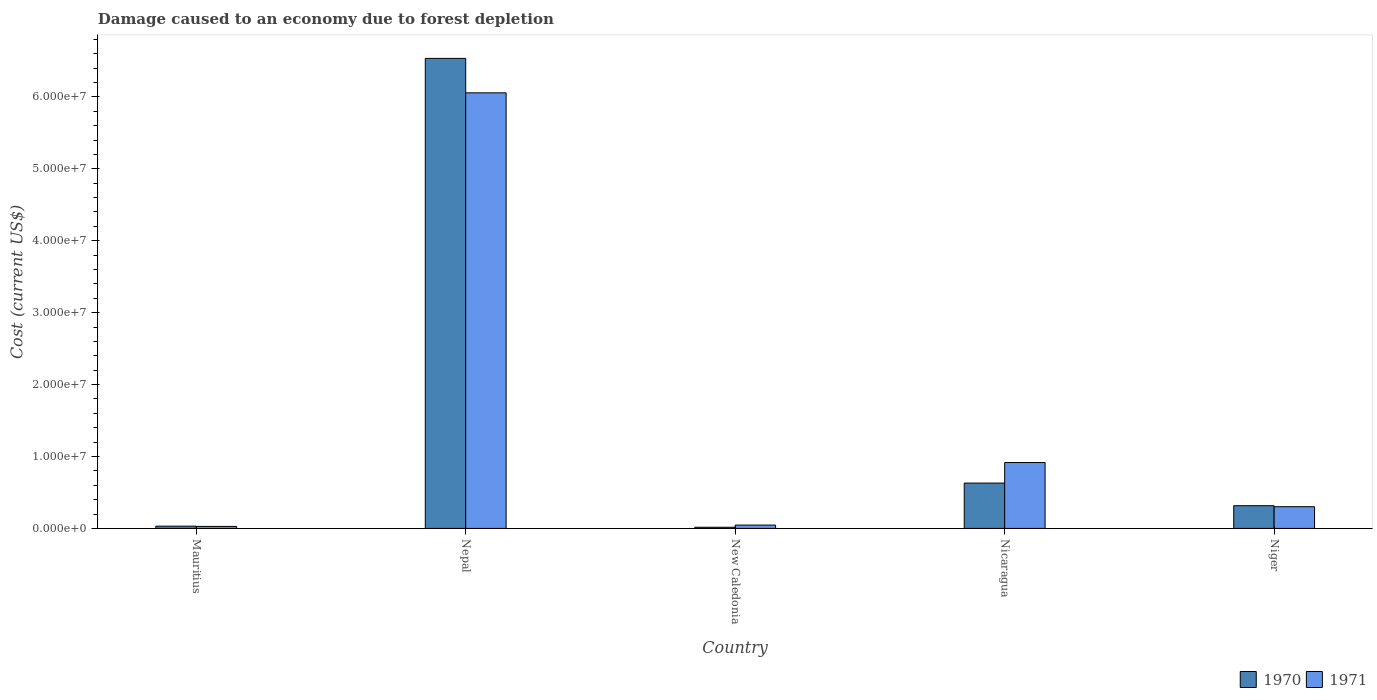How many groups of bars are there?
Ensure brevity in your answer.  5. Are the number of bars per tick equal to the number of legend labels?
Offer a terse response. Yes. How many bars are there on the 3rd tick from the left?
Keep it short and to the point. 2. What is the label of the 1st group of bars from the left?
Make the answer very short. Mauritius. In how many cases, is the number of bars for a given country not equal to the number of legend labels?
Provide a succinct answer. 0. What is the cost of damage caused due to forest depletion in 1971 in Nicaragua?
Ensure brevity in your answer.  9.16e+06. Across all countries, what is the maximum cost of damage caused due to forest depletion in 1971?
Provide a short and direct response. 6.06e+07. Across all countries, what is the minimum cost of damage caused due to forest depletion in 1971?
Your response must be concise. 2.78e+05. In which country was the cost of damage caused due to forest depletion in 1970 maximum?
Keep it short and to the point. Nepal. In which country was the cost of damage caused due to forest depletion in 1970 minimum?
Keep it short and to the point. New Caledonia. What is the total cost of damage caused due to forest depletion in 1971 in the graph?
Provide a succinct answer. 7.35e+07. What is the difference between the cost of damage caused due to forest depletion in 1971 in Mauritius and that in New Caledonia?
Make the answer very short. -1.87e+05. What is the difference between the cost of damage caused due to forest depletion in 1971 in Mauritius and the cost of damage caused due to forest depletion in 1970 in Niger?
Keep it short and to the point. -2.88e+06. What is the average cost of damage caused due to forest depletion in 1970 per country?
Ensure brevity in your answer.  1.51e+07. What is the difference between the cost of damage caused due to forest depletion of/in 1970 and cost of damage caused due to forest depletion of/in 1971 in Nepal?
Your answer should be compact. 4.79e+06. In how many countries, is the cost of damage caused due to forest depletion in 1971 greater than 34000000 US$?
Your answer should be very brief. 1. What is the ratio of the cost of damage caused due to forest depletion in 1970 in Mauritius to that in Nicaragua?
Keep it short and to the point. 0.05. Is the cost of damage caused due to forest depletion in 1970 in Mauritius less than that in Nepal?
Provide a short and direct response. Yes. What is the difference between the highest and the second highest cost of damage caused due to forest depletion in 1970?
Your answer should be compact. 6.22e+07. What is the difference between the highest and the lowest cost of damage caused due to forest depletion in 1970?
Give a very brief answer. 6.52e+07. Are all the bars in the graph horizontal?
Provide a succinct answer. No. How many countries are there in the graph?
Your response must be concise. 5. What is the difference between two consecutive major ticks on the Y-axis?
Keep it short and to the point. 1.00e+07. Are the values on the major ticks of Y-axis written in scientific E-notation?
Offer a terse response. Yes. Does the graph contain any zero values?
Ensure brevity in your answer.  No. Where does the legend appear in the graph?
Offer a very short reply. Bottom right. How many legend labels are there?
Your response must be concise. 2. How are the legend labels stacked?
Your answer should be compact. Horizontal. What is the title of the graph?
Offer a very short reply. Damage caused to an economy due to forest depletion. Does "2009" appear as one of the legend labels in the graph?
Your answer should be very brief. No. What is the label or title of the X-axis?
Offer a very short reply. Country. What is the label or title of the Y-axis?
Provide a succinct answer. Cost (current US$). What is the Cost (current US$) of 1970 in Mauritius?
Your response must be concise. 3.14e+05. What is the Cost (current US$) in 1971 in Mauritius?
Ensure brevity in your answer.  2.78e+05. What is the Cost (current US$) in 1970 in Nepal?
Your answer should be compact. 6.54e+07. What is the Cost (current US$) in 1971 in Nepal?
Your response must be concise. 6.06e+07. What is the Cost (current US$) of 1970 in New Caledonia?
Your answer should be compact. 1.60e+05. What is the Cost (current US$) of 1971 in New Caledonia?
Offer a very short reply. 4.65e+05. What is the Cost (current US$) of 1970 in Nicaragua?
Keep it short and to the point. 6.30e+06. What is the Cost (current US$) of 1971 in Nicaragua?
Make the answer very short. 9.16e+06. What is the Cost (current US$) of 1970 in Niger?
Your response must be concise. 3.16e+06. What is the Cost (current US$) in 1971 in Niger?
Ensure brevity in your answer.  3.02e+06. Across all countries, what is the maximum Cost (current US$) in 1970?
Your answer should be very brief. 6.54e+07. Across all countries, what is the maximum Cost (current US$) of 1971?
Your response must be concise. 6.06e+07. Across all countries, what is the minimum Cost (current US$) in 1970?
Your answer should be compact. 1.60e+05. Across all countries, what is the minimum Cost (current US$) of 1971?
Ensure brevity in your answer.  2.78e+05. What is the total Cost (current US$) in 1970 in the graph?
Make the answer very short. 7.53e+07. What is the total Cost (current US$) in 1971 in the graph?
Make the answer very short. 7.35e+07. What is the difference between the Cost (current US$) in 1970 in Mauritius and that in Nepal?
Keep it short and to the point. -6.50e+07. What is the difference between the Cost (current US$) of 1971 in Mauritius and that in Nepal?
Make the answer very short. -6.03e+07. What is the difference between the Cost (current US$) of 1970 in Mauritius and that in New Caledonia?
Make the answer very short. 1.54e+05. What is the difference between the Cost (current US$) in 1971 in Mauritius and that in New Caledonia?
Provide a short and direct response. -1.87e+05. What is the difference between the Cost (current US$) of 1970 in Mauritius and that in Nicaragua?
Provide a succinct answer. -5.99e+06. What is the difference between the Cost (current US$) in 1971 in Mauritius and that in Nicaragua?
Offer a terse response. -8.88e+06. What is the difference between the Cost (current US$) in 1970 in Mauritius and that in Niger?
Your answer should be compact. -2.84e+06. What is the difference between the Cost (current US$) of 1971 in Mauritius and that in Niger?
Keep it short and to the point. -2.74e+06. What is the difference between the Cost (current US$) of 1970 in Nepal and that in New Caledonia?
Keep it short and to the point. 6.52e+07. What is the difference between the Cost (current US$) in 1971 in Nepal and that in New Caledonia?
Provide a short and direct response. 6.01e+07. What is the difference between the Cost (current US$) in 1970 in Nepal and that in Nicaragua?
Make the answer very short. 5.90e+07. What is the difference between the Cost (current US$) in 1971 in Nepal and that in Nicaragua?
Ensure brevity in your answer.  5.14e+07. What is the difference between the Cost (current US$) of 1970 in Nepal and that in Niger?
Your answer should be very brief. 6.22e+07. What is the difference between the Cost (current US$) of 1971 in Nepal and that in Niger?
Make the answer very short. 5.75e+07. What is the difference between the Cost (current US$) in 1970 in New Caledonia and that in Nicaragua?
Keep it short and to the point. -6.14e+06. What is the difference between the Cost (current US$) in 1971 in New Caledonia and that in Nicaragua?
Provide a succinct answer. -8.69e+06. What is the difference between the Cost (current US$) of 1970 in New Caledonia and that in Niger?
Your answer should be very brief. -3.00e+06. What is the difference between the Cost (current US$) of 1971 in New Caledonia and that in Niger?
Make the answer very short. -2.55e+06. What is the difference between the Cost (current US$) in 1970 in Nicaragua and that in Niger?
Your answer should be compact. 3.15e+06. What is the difference between the Cost (current US$) of 1971 in Nicaragua and that in Niger?
Keep it short and to the point. 6.14e+06. What is the difference between the Cost (current US$) of 1970 in Mauritius and the Cost (current US$) of 1971 in Nepal?
Keep it short and to the point. -6.02e+07. What is the difference between the Cost (current US$) of 1970 in Mauritius and the Cost (current US$) of 1971 in New Caledonia?
Ensure brevity in your answer.  -1.52e+05. What is the difference between the Cost (current US$) of 1970 in Mauritius and the Cost (current US$) of 1971 in Nicaragua?
Your response must be concise. -8.85e+06. What is the difference between the Cost (current US$) of 1970 in Mauritius and the Cost (current US$) of 1971 in Niger?
Offer a very short reply. -2.71e+06. What is the difference between the Cost (current US$) in 1970 in Nepal and the Cost (current US$) in 1971 in New Caledonia?
Your response must be concise. 6.49e+07. What is the difference between the Cost (current US$) of 1970 in Nepal and the Cost (current US$) of 1971 in Nicaragua?
Ensure brevity in your answer.  5.62e+07. What is the difference between the Cost (current US$) of 1970 in Nepal and the Cost (current US$) of 1971 in Niger?
Give a very brief answer. 6.23e+07. What is the difference between the Cost (current US$) in 1970 in New Caledonia and the Cost (current US$) in 1971 in Nicaragua?
Provide a succinct answer. -9.00e+06. What is the difference between the Cost (current US$) in 1970 in New Caledonia and the Cost (current US$) in 1971 in Niger?
Ensure brevity in your answer.  -2.86e+06. What is the difference between the Cost (current US$) in 1970 in Nicaragua and the Cost (current US$) in 1971 in Niger?
Ensure brevity in your answer.  3.28e+06. What is the average Cost (current US$) of 1970 per country?
Provide a succinct answer. 1.51e+07. What is the average Cost (current US$) in 1971 per country?
Provide a succinct answer. 1.47e+07. What is the difference between the Cost (current US$) in 1970 and Cost (current US$) in 1971 in Mauritius?
Provide a short and direct response. 3.52e+04. What is the difference between the Cost (current US$) in 1970 and Cost (current US$) in 1971 in Nepal?
Give a very brief answer. 4.79e+06. What is the difference between the Cost (current US$) of 1970 and Cost (current US$) of 1971 in New Caledonia?
Your answer should be compact. -3.05e+05. What is the difference between the Cost (current US$) of 1970 and Cost (current US$) of 1971 in Nicaragua?
Keep it short and to the point. -2.86e+06. What is the difference between the Cost (current US$) in 1970 and Cost (current US$) in 1971 in Niger?
Your response must be concise. 1.37e+05. What is the ratio of the Cost (current US$) in 1970 in Mauritius to that in Nepal?
Give a very brief answer. 0. What is the ratio of the Cost (current US$) in 1971 in Mauritius to that in Nepal?
Your response must be concise. 0. What is the ratio of the Cost (current US$) of 1970 in Mauritius to that in New Caledonia?
Give a very brief answer. 1.96. What is the ratio of the Cost (current US$) in 1971 in Mauritius to that in New Caledonia?
Keep it short and to the point. 0.6. What is the ratio of the Cost (current US$) in 1970 in Mauritius to that in Nicaragua?
Provide a succinct answer. 0.05. What is the ratio of the Cost (current US$) in 1971 in Mauritius to that in Nicaragua?
Keep it short and to the point. 0.03. What is the ratio of the Cost (current US$) of 1970 in Mauritius to that in Niger?
Provide a short and direct response. 0.1. What is the ratio of the Cost (current US$) in 1971 in Mauritius to that in Niger?
Make the answer very short. 0.09. What is the ratio of the Cost (current US$) of 1970 in Nepal to that in New Caledonia?
Provide a succinct answer. 409.45. What is the ratio of the Cost (current US$) of 1971 in Nepal to that in New Caledonia?
Offer a terse response. 130.21. What is the ratio of the Cost (current US$) in 1970 in Nepal to that in Nicaragua?
Give a very brief answer. 10.37. What is the ratio of the Cost (current US$) in 1971 in Nepal to that in Nicaragua?
Offer a very short reply. 6.61. What is the ratio of the Cost (current US$) in 1970 in Nepal to that in Niger?
Your answer should be very brief. 20.71. What is the ratio of the Cost (current US$) in 1971 in Nepal to that in Niger?
Your response must be concise. 20.06. What is the ratio of the Cost (current US$) in 1970 in New Caledonia to that in Nicaragua?
Keep it short and to the point. 0.03. What is the ratio of the Cost (current US$) of 1971 in New Caledonia to that in Nicaragua?
Offer a terse response. 0.05. What is the ratio of the Cost (current US$) in 1970 in New Caledonia to that in Niger?
Provide a succinct answer. 0.05. What is the ratio of the Cost (current US$) in 1971 in New Caledonia to that in Niger?
Provide a short and direct response. 0.15. What is the ratio of the Cost (current US$) of 1970 in Nicaragua to that in Niger?
Your response must be concise. 2. What is the ratio of the Cost (current US$) in 1971 in Nicaragua to that in Niger?
Offer a terse response. 3.03. What is the difference between the highest and the second highest Cost (current US$) in 1970?
Offer a terse response. 5.90e+07. What is the difference between the highest and the second highest Cost (current US$) of 1971?
Ensure brevity in your answer.  5.14e+07. What is the difference between the highest and the lowest Cost (current US$) in 1970?
Ensure brevity in your answer.  6.52e+07. What is the difference between the highest and the lowest Cost (current US$) in 1971?
Your answer should be compact. 6.03e+07. 